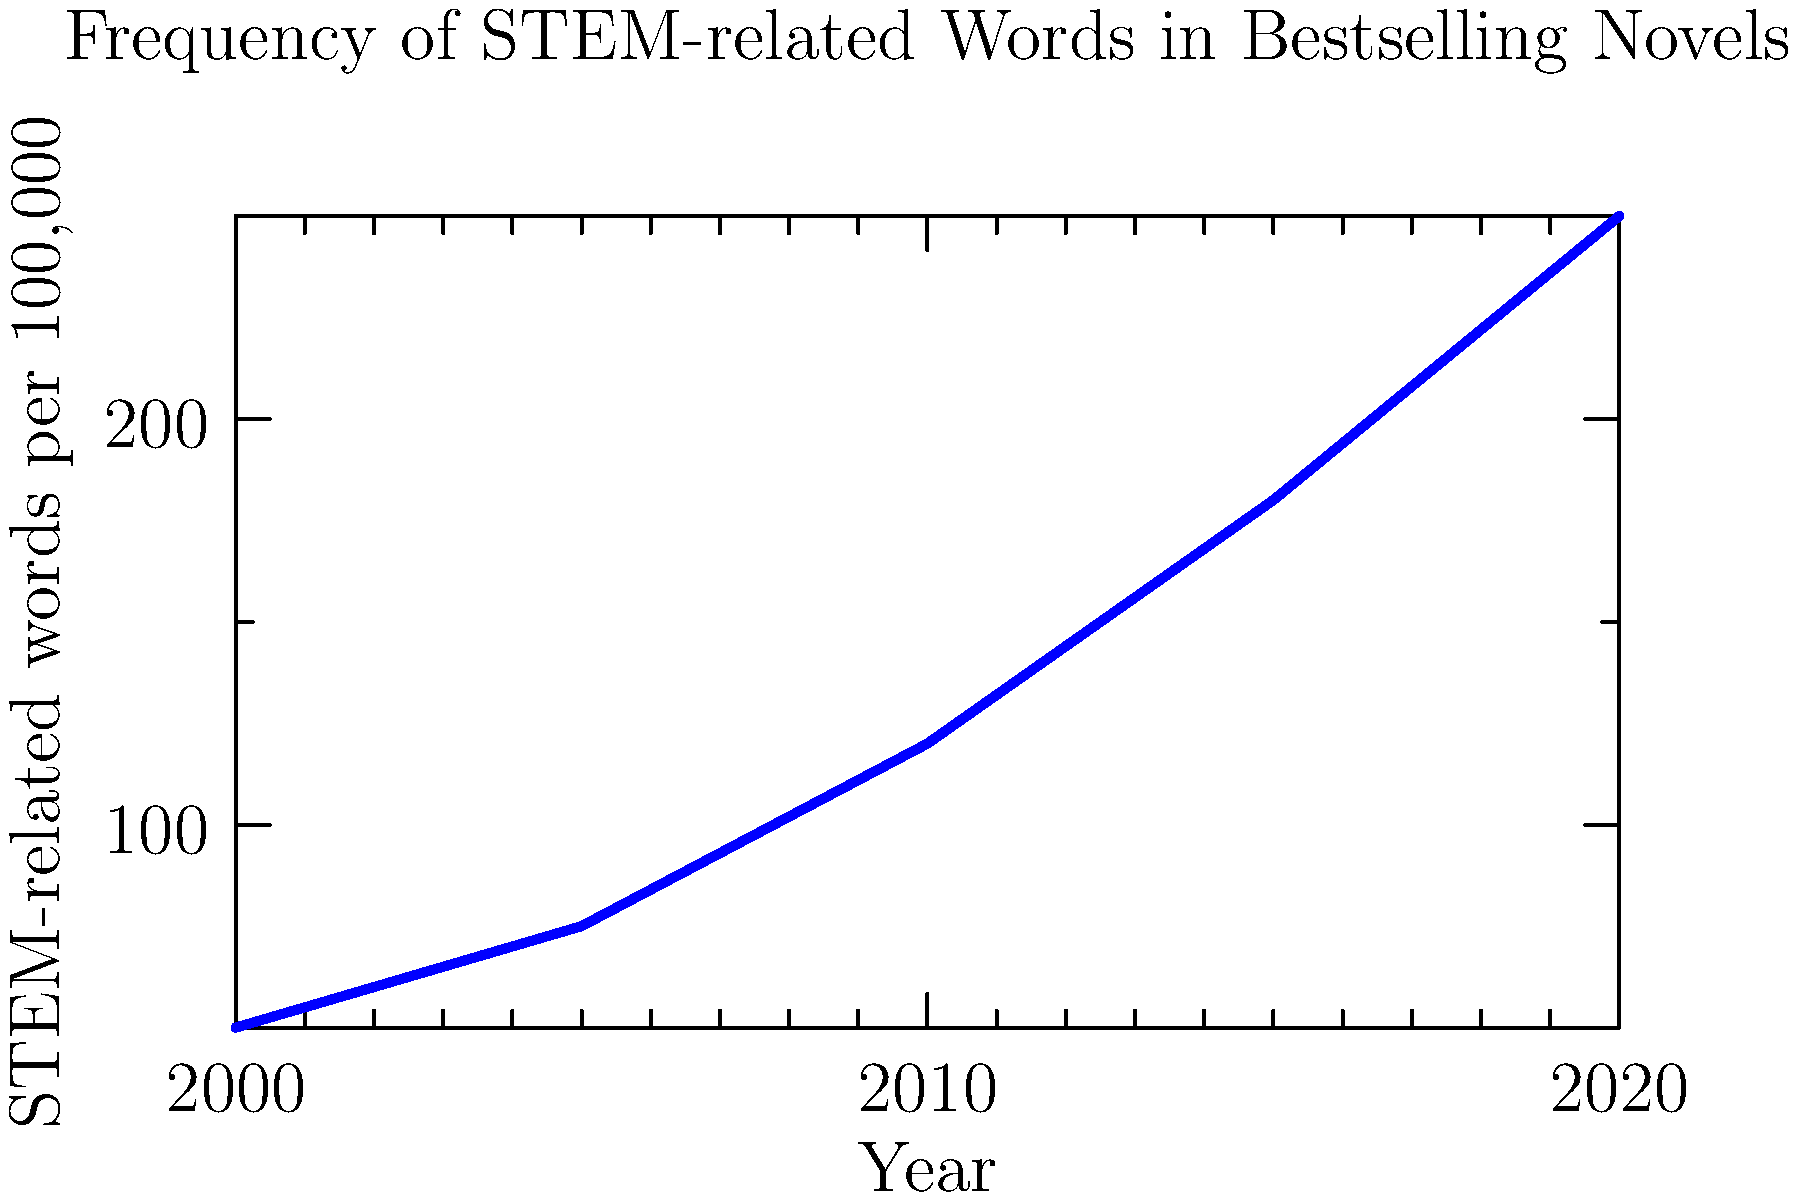Based on the line graph showing the frequency of STEM-related words in bestselling novels from 2000 to 2020, what literary trend does this data suggest, and how might it reflect changing societal attitudes towards science and technology in contemporary literature? To analyze this graph and its implications for contemporary literature, let's follow these steps:

1. Observe the trend: The graph shows a clear upward trend in the frequency of STEM-related words in bestselling novels from 2000 to 2020.

2. Quantify the change: The frequency increases from about 50 words per 100,000 in 2000 to 250 words per 100,000 in 2020, a five-fold increase over 20 years.

3. Consider the literary implications: This trend suggests that STEM topics are becoming more prevalent in popular literature. Authors may be incorporating more scientific and technological themes, concepts, or jargon into their narratives.

4. Reflect on societal attitudes: The increasing presence of STEM vocabulary in bestselling novels likely reflects a growing public interest in and familiarity with scientific and technological concepts. This could be due to the rapid technological advancements and their impact on daily life during this period.

5. Analyze the literary-cultural intersection: This trend may indicate a blurring of boundaries between literary and scientific discourses. It suggests that contemporary literature is increasingly engaging with STEM fields, possibly as a way to explore the human condition in a technologically-driven world.

6. Consider the role of genre: The rise in STEM-related words could be partially attributed to the growing popularity of science fiction and techno-thrillers, genres that often incorporate scientific and technological elements.

7. Examine potential influences: Factors such as increased STEM education, the ubiquity of technology in everyday life, and high-profile scientific achievements (e.g., space exploration, genome sequencing) may have influenced both authors and readers, leading to greater integration of STEM concepts in popular literature.

This trend suggests a significant shift in contemporary literature towards a more scientifically informed narrative landscape, reflecting and potentially shaping societal attitudes towards science and technology.
Answer: Increasing integration of STEM in contemporary literature, reflecting growing societal engagement with science and technology. 